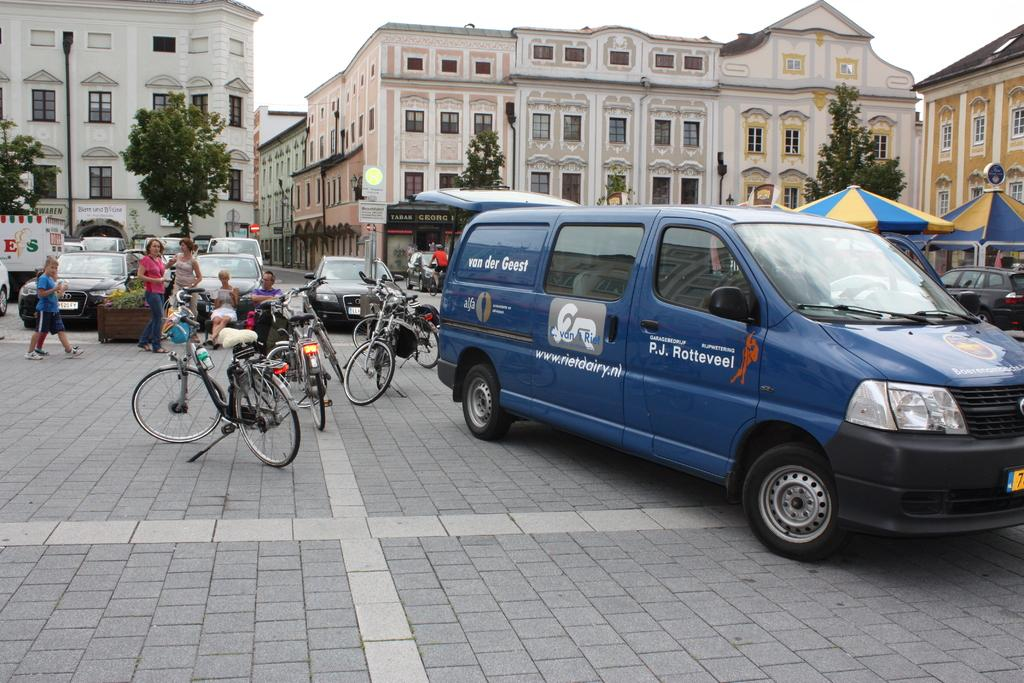Provide a one-sentence caption for the provided image. A blue van next to some bicycles; the van has the words van der Geest on its side. 